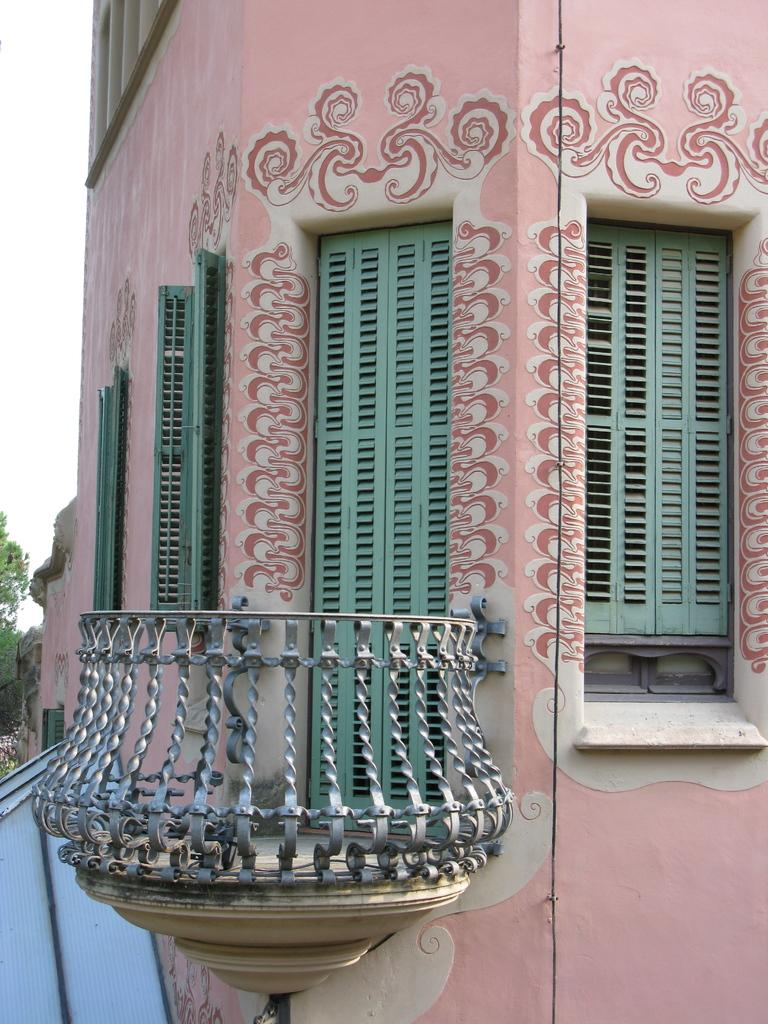What is the main subject of the picture? The main subject of the picture is a building. What specific features can be observed on the building? The building has windows. What else can be seen in the picture besides the building? There are objects and trees in the background of the picture. What is visible in the background of the picture? The sky is visible in the background of the picture. How does the building take a trip in the picture? The building does not take a trip in the picture; it is stationary. Can you describe the flight of the birds in the image? There are no birds present in the image, so it is not possible to describe their flight. 